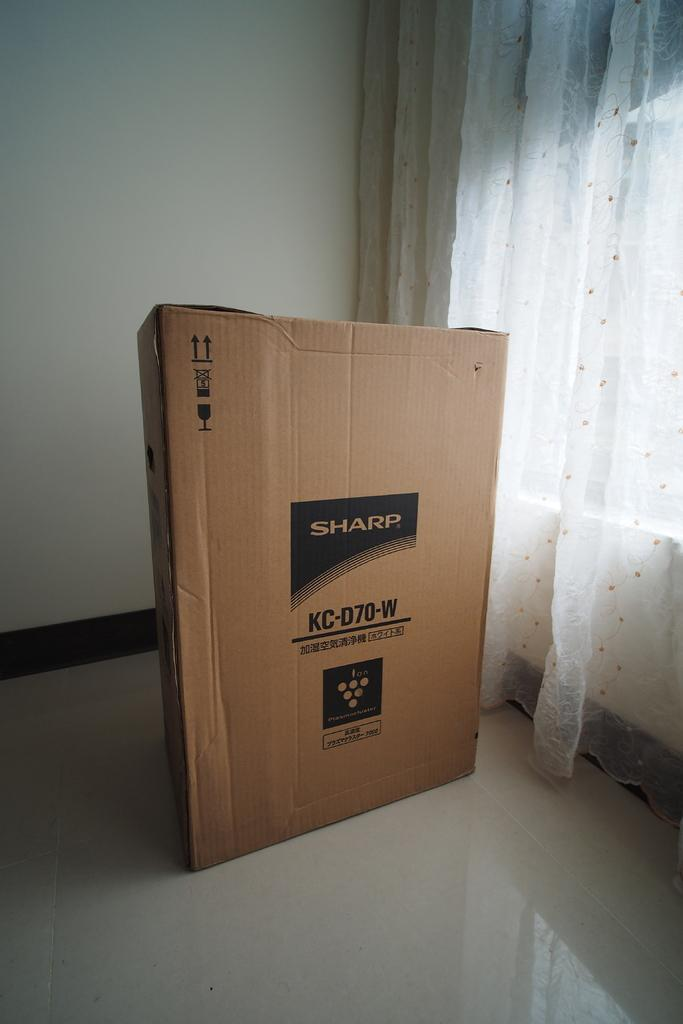<image>
Present a compact description of the photo's key features. A Sharp TV box in an empty room with white curtains. 